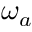Convert formula to latex. <formula><loc_0><loc_0><loc_500><loc_500>\omega _ { a }</formula> 